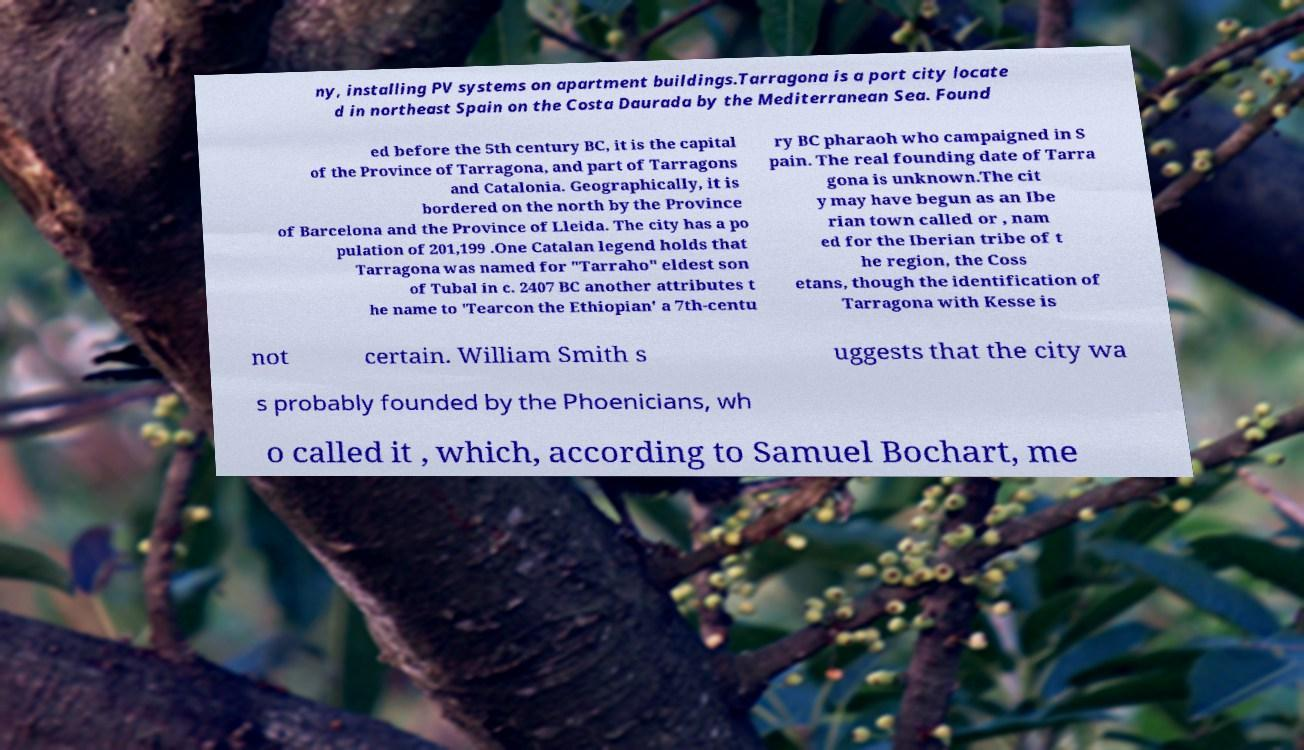I need the written content from this picture converted into text. Can you do that? ny, installing PV systems on apartment buildings.Tarragona is a port city locate d in northeast Spain on the Costa Daurada by the Mediterranean Sea. Found ed before the 5th century BC, it is the capital of the Province of Tarragona, and part of Tarragons and Catalonia. Geographically, it is bordered on the north by the Province of Barcelona and the Province of Lleida. The city has a po pulation of 201,199 .One Catalan legend holds that Tarragona was named for "Tarraho" eldest son of Tubal in c. 2407 BC another attributes t he name to 'Tearcon the Ethiopian' a 7th-centu ry BC pharaoh who campaigned in S pain. The real founding date of Tarra gona is unknown.The cit y may have begun as an Ibe rian town called or , nam ed for the Iberian tribe of t he region, the Coss etans, though the identification of Tarragona with Kesse is not certain. William Smith s uggests that the city wa s probably founded by the Phoenicians, wh o called it , which, according to Samuel Bochart, me 